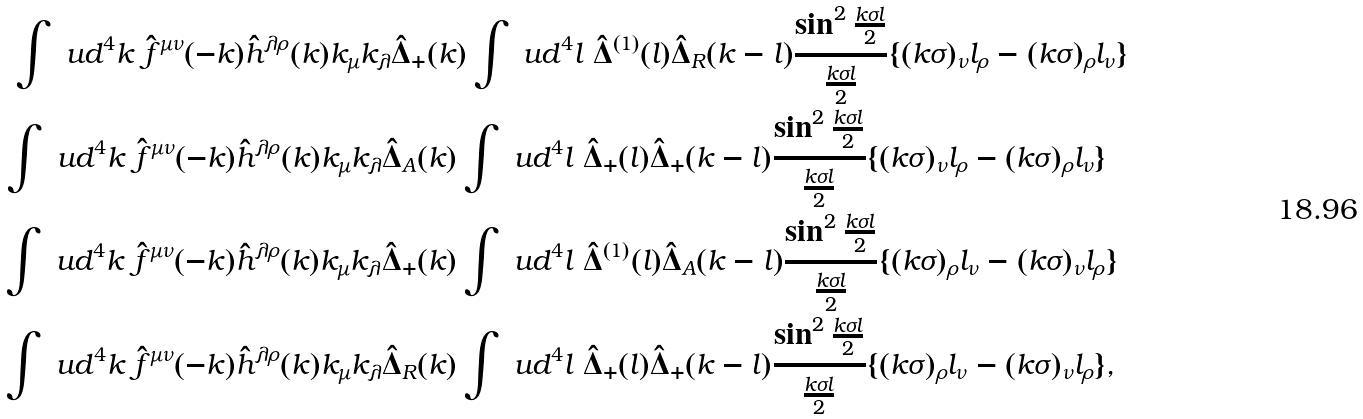<formula> <loc_0><loc_0><loc_500><loc_500>\int \ u d ^ { 4 } k \ \hat { f } ^ { \mu \nu } ( - k ) \hat { h } ^ { \lambda \rho } ( k ) k _ { \mu } k _ { \lambda } \hat { \Delta } _ { + } ( k ) \int \ u d ^ { 4 } & l \ \hat { \Delta } ^ { ( 1 ) } ( l ) \hat { \Delta } _ { R } ( k - l ) \frac { \sin ^ { 2 } \frac { k \sigma l } { 2 } } { \frac { k \sigma l } { 2 } } \{ ( k \sigma ) _ { \nu } l _ { \rho } - ( k \sigma ) _ { \rho } l _ { \nu } \} \\ \int \ u d ^ { 4 } k \ \hat { f } ^ { \mu \nu } ( - k ) \hat { h } ^ { \lambda \rho } ( k ) k _ { \mu } k _ { \lambda } \hat { \Delta } _ { A } ( k ) \int \ u d ^ { 4 } l & \ \hat { \Delta } _ { + } ( l ) \hat { \Delta } _ { + } ( k - l ) \frac { \sin ^ { 2 } \frac { k \sigma l } { 2 } } { \frac { k \sigma l } { 2 } } \{ ( k \sigma ) _ { \nu } l _ { \rho } - ( k \sigma ) _ { \rho } l _ { \nu } \} \\ \int \ u d ^ { 4 } k \ \hat { f } ^ { \mu \nu } ( - k ) \hat { h } ^ { \lambda \rho } ( k ) k _ { \mu } k _ { \lambda } \hat { \Delta } _ { + } ( k ) \int \ u d ^ { 4 } l & \ \hat { \Delta } ^ { ( 1 ) } ( l ) \hat { \Delta } _ { A } ( k - l ) \frac { \sin ^ { 2 } \frac { k \sigma l } { 2 } } { \frac { k \sigma l } { 2 } } \{ ( k \sigma ) _ { \rho } l _ { \nu } - ( k \sigma ) _ { \nu } l _ { \rho } \} \\ \int \ u d ^ { 4 } k \ \hat { f } ^ { \mu \nu } ( - k ) \hat { h } ^ { \lambda \rho } ( k ) k _ { \mu } k _ { \lambda } \hat { \Delta } _ { R } ( k ) \int \ u d ^ { 4 } l & \ \hat { \Delta } _ { + } ( l ) \hat { \Delta } _ { + } ( k - l ) \frac { \sin ^ { 2 } \frac { k \sigma l } { 2 } } { \frac { k \sigma l } { 2 } } \{ ( k \sigma ) _ { \rho } l _ { \nu } - ( k \sigma ) _ { \nu } l _ { \rho } \} ,</formula> 